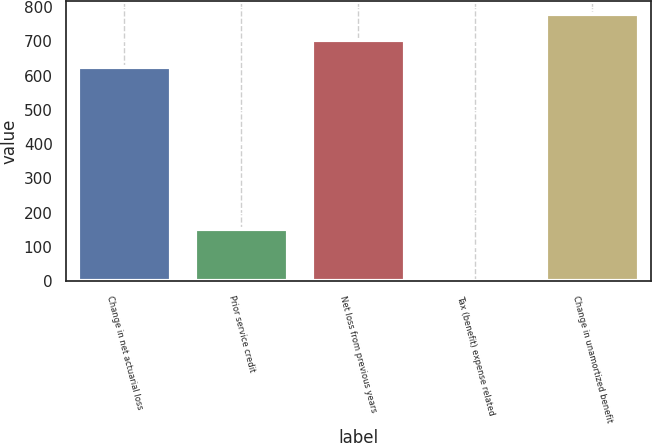Convert chart to OTSL. <chart><loc_0><loc_0><loc_500><loc_500><bar_chart><fcel>Change in net actuarial loss<fcel>Prior service credit<fcel>Net loss from previous years<fcel>Tax (benefit) expense related<fcel>Change in unamortized benefit<nl><fcel>626<fcel>154<fcel>702.5<fcel>1<fcel>779<nl></chart> 